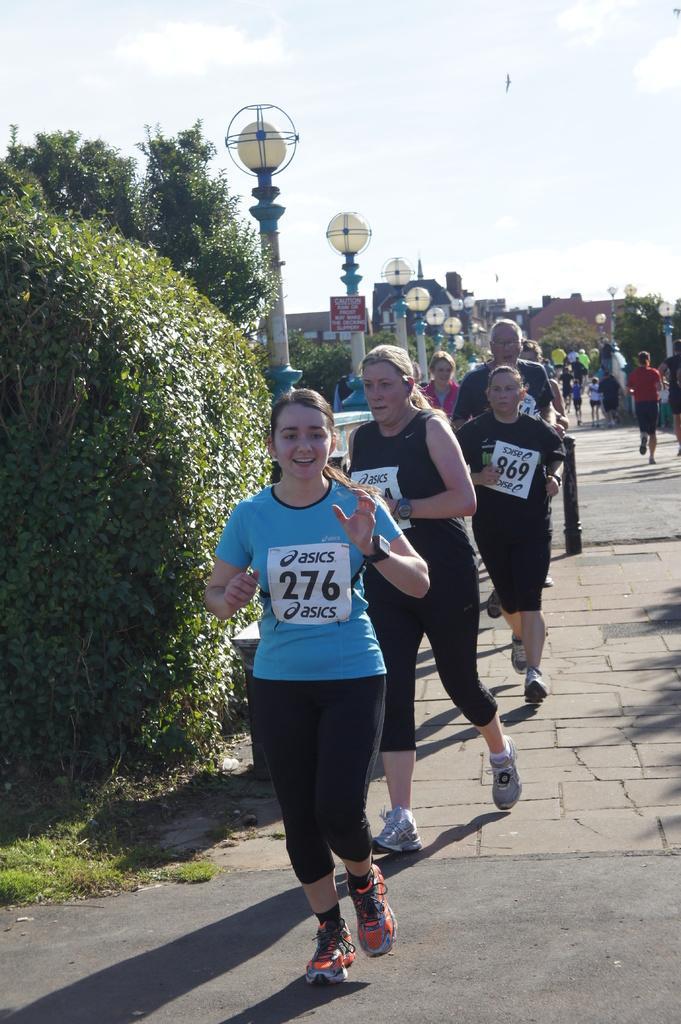Describe this image in one or two sentences. In this image people are running on the road. At the left side of the image there are lights and at the background there are building, trees. At the top there is sky. 